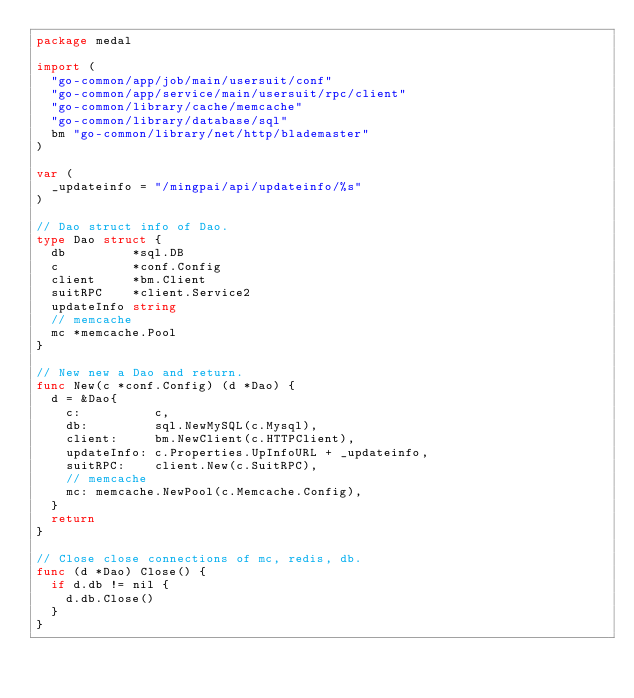Convert code to text. <code><loc_0><loc_0><loc_500><loc_500><_Go_>package medal

import (
	"go-common/app/job/main/usersuit/conf"
	"go-common/app/service/main/usersuit/rpc/client"
	"go-common/library/cache/memcache"
	"go-common/library/database/sql"
	bm "go-common/library/net/http/blademaster"
)

var (
	_updateinfo = "/mingpai/api/updateinfo/%s"
)

// Dao struct info of Dao.
type Dao struct {
	db         *sql.DB
	c          *conf.Config
	client     *bm.Client
	suitRPC    *client.Service2
	updateInfo string
	// memcache
	mc *memcache.Pool
}

// New new a Dao and return.
func New(c *conf.Config) (d *Dao) {
	d = &Dao{
		c:          c,
		db:         sql.NewMySQL(c.Mysql),
		client:     bm.NewClient(c.HTTPClient),
		updateInfo: c.Properties.UpInfoURL + _updateinfo,
		suitRPC:    client.New(c.SuitRPC),
		// memcache
		mc: memcache.NewPool(c.Memcache.Config),
	}
	return
}

// Close close connections of mc, redis, db.
func (d *Dao) Close() {
	if d.db != nil {
		d.db.Close()
	}
}
</code> 